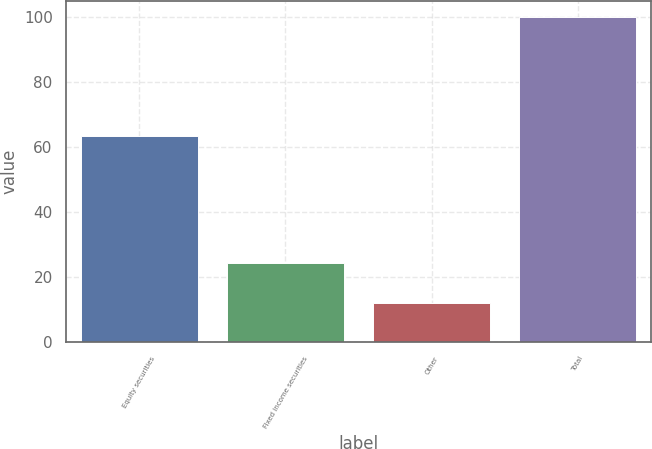Convert chart to OTSL. <chart><loc_0><loc_0><loc_500><loc_500><bar_chart><fcel>Equity securities<fcel>Fixed income securities<fcel>Other<fcel>Total<nl><fcel>63.4<fcel>24.5<fcel>12.1<fcel>100<nl></chart> 